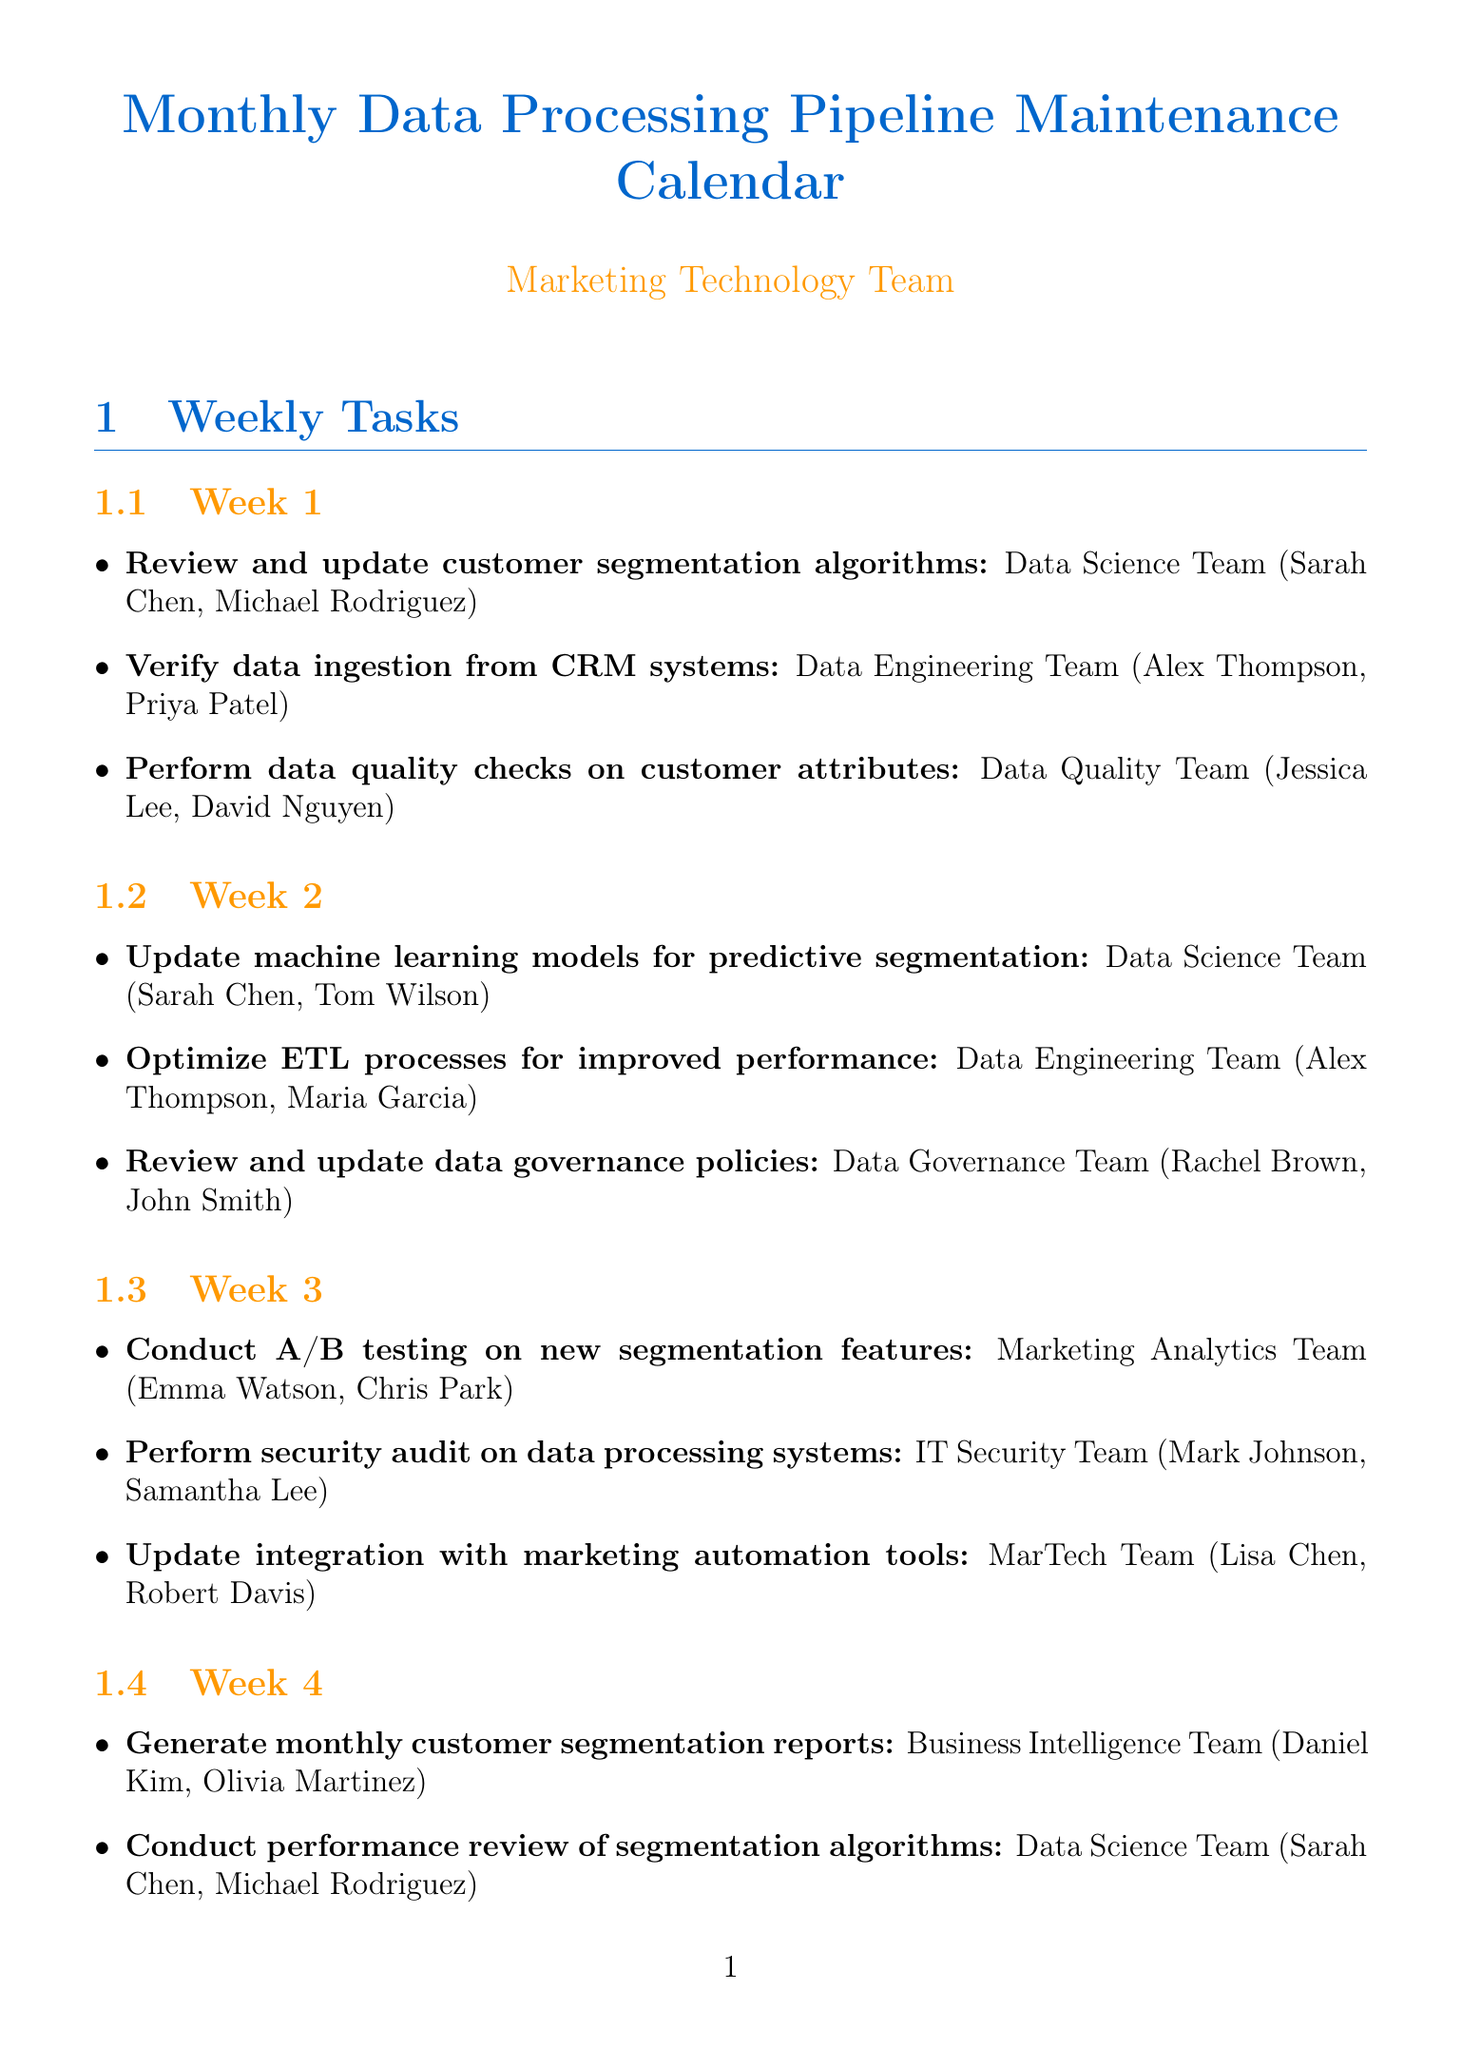What is the task for Week 1 related to customer segmentation algorithms? The task listed for Week 1 regarding customer segmentation algorithms is "Review and update customer segmentation algorithms."
Answer: Review and update customer segmentation algorithms Who is responsible for verifying data ingestion from CRM systems in Week 1? The responsible team for this task in Week 1 is the Data Engineering Team.
Answer: Data Engineering Team Which team conducts A/B testing in Week 3? The team responsible for A/B testing new segmentation features in Week 3 is the Marketing Analytics Team.
Answer: Marketing Analytics Team How many team members are involved in the task of "Update integration with marketing automation tools"? The task involves two team members listed under the MarTech Team.
Answer: Two team members What is the frequency of the "Quarterly review of customer segmentation strategy"? The document specifies that this task occurs every three months.
Answer: Every 3 months Who are the team members responsible for optimizing ETL processes in Week 2? The responsible team members for this task are Alex Thompson and Maria Garcia from the Data Engineering Team.
Answer: Alex Thompson, Maria Garcia What type of document is this? This document is a maintenance calendar related to data processing pipelines.
Answer: Maintenance calendar What tool is used for workflow management and scheduling? The tool designated for this purpose is Apache Airflow.
Answer: Apache Airflow 